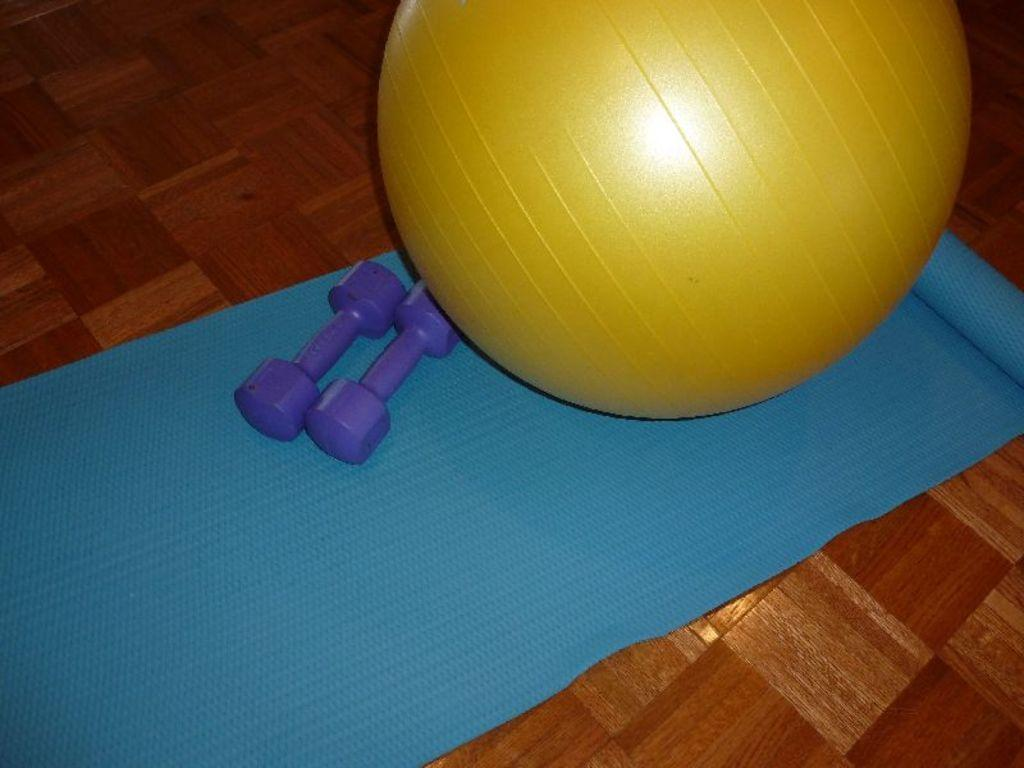What is on the floor in the image? There is an exercise mat on the floor. What exercise equipment can be seen in the image? There is an exercise ball and dumbbells in the image. What type of food is the cook preparing on the exercise mat in the image? There is no cook or food preparation present in the image; it features exercise equipment on an exercise mat. What type of religious ceremony is the minister conducting on the exercise mat in the image? There is no minister or religious ceremony present in the image; it features exercise equipment on an exercise mat. 